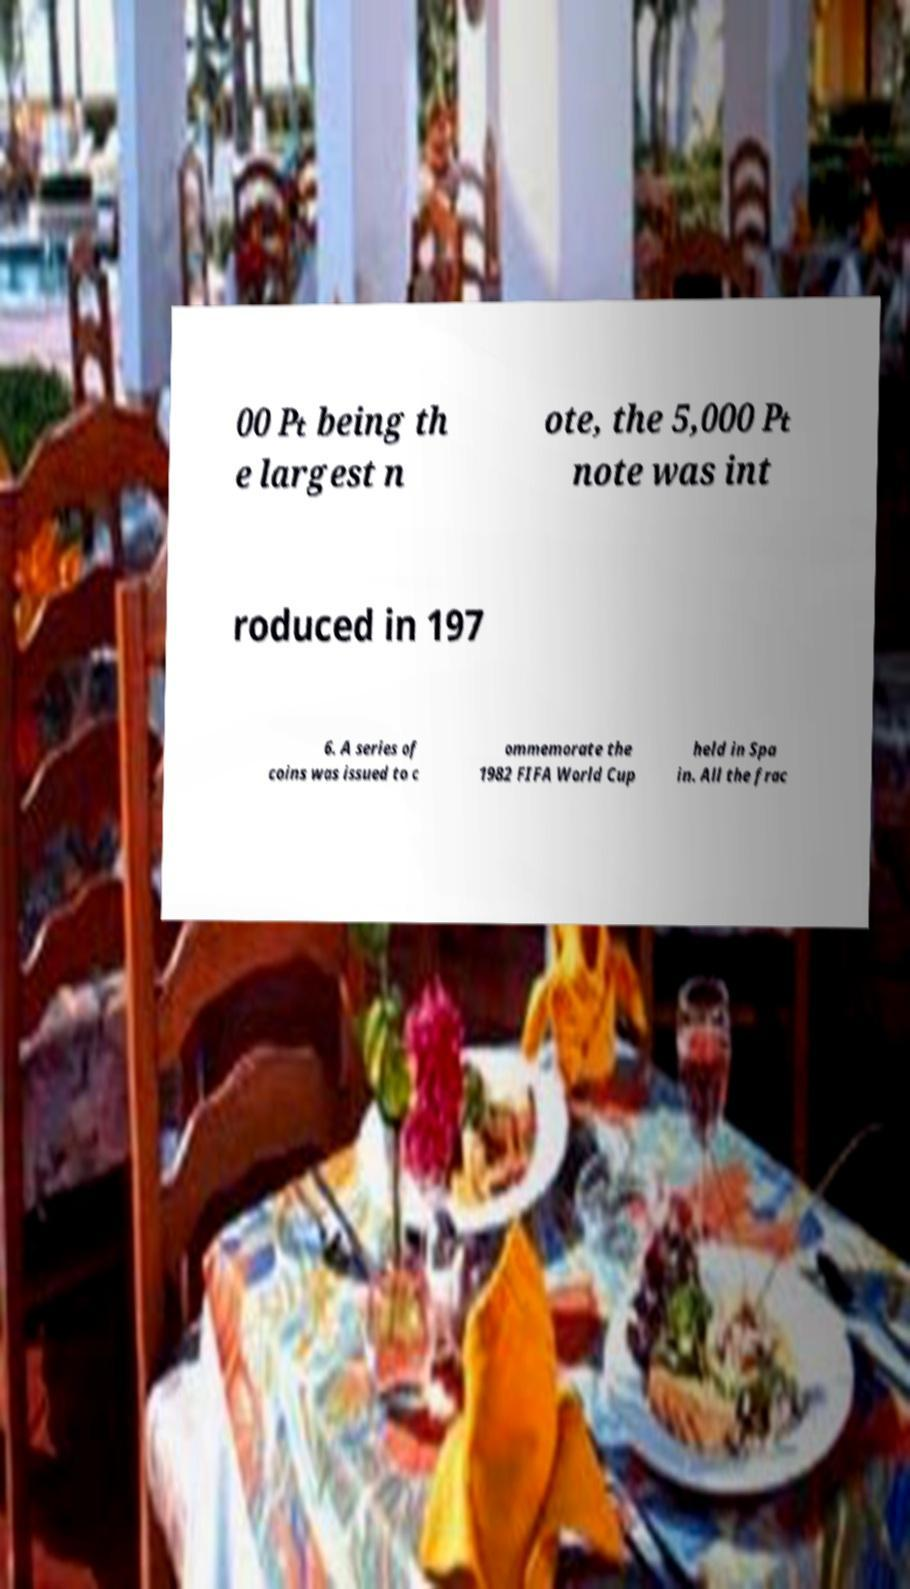There's text embedded in this image that I need extracted. Can you transcribe it verbatim? 00 ₧ being th e largest n ote, the 5,000 ₧ note was int roduced in 197 6. A series of coins was issued to c ommemorate the 1982 FIFA World Cup held in Spa in. All the frac 